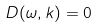Convert formula to latex. <formula><loc_0><loc_0><loc_500><loc_500>D ( \omega , k ) = 0</formula> 